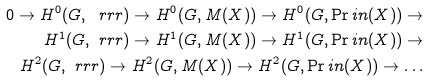Convert formula to latex. <formula><loc_0><loc_0><loc_500><loc_500>0 \rightarrow H ^ { 0 } ( G , \ r r r ) \rightarrow H ^ { 0 } ( G , M ( X ) ) \rightarrow H ^ { 0 } ( G , \Pr i n ( X ) ) \rightarrow \\ H ^ { 1 } ( G , \ r r r ) \rightarrow H ^ { 1 } ( G , M ( X ) ) \rightarrow H ^ { 1 } ( G , \Pr i n ( X ) ) \rightarrow \\ H ^ { 2 } ( G , \ r r r ) \rightarrow H ^ { 2 } ( G , M ( X ) ) \rightarrow H ^ { 2 } ( G , \Pr i n ( X ) ) \rightarrow \dots</formula> 